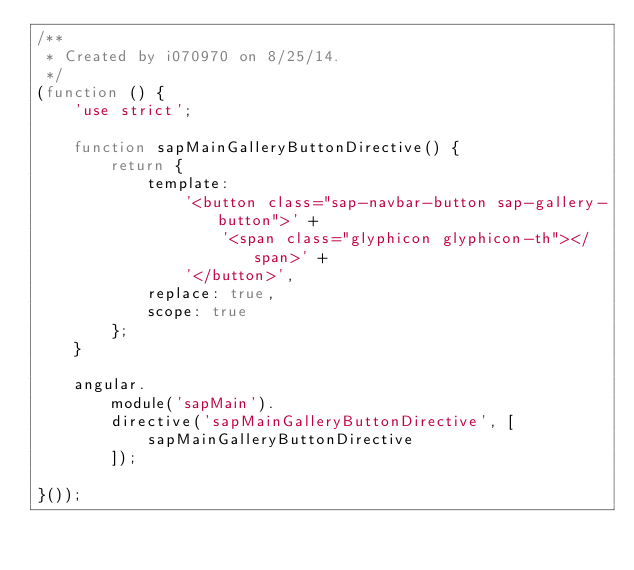Convert code to text. <code><loc_0><loc_0><loc_500><loc_500><_JavaScript_>/**
 * Created by i070970 on 8/25/14.
 */
(function () {
    'use strict';

    function sapMainGalleryButtonDirective() {
        return {
            template:
                '<button class="sap-navbar-button sap-gallery-button">' +
                    '<span class="glyphicon glyphicon-th"></span>' +
                '</button>',
            replace: true,
            scope: true
        };
    }

    angular.
        module('sapMain').
        directive('sapMainGalleryButtonDirective', [
            sapMainGalleryButtonDirective
        ]);

}());</code> 